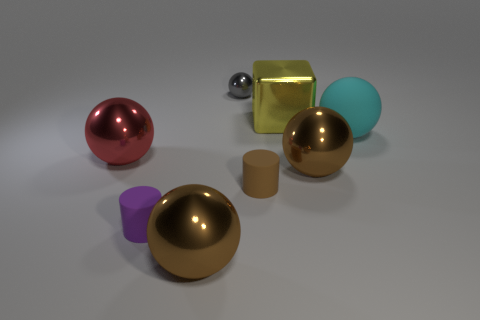Subtract all gray metal balls. How many balls are left? 4 Subtract all gray cylinders. How many brown spheres are left? 2 Subtract 2 spheres. How many spheres are left? 3 Subtract all red balls. How many balls are left? 4 Add 1 large shiny cubes. How many objects exist? 9 Subtract all cylinders. How many objects are left? 6 Subtract all gray spheres. Subtract all purple blocks. How many spheres are left? 4 Add 4 rubber objects. How many rubber objects are left? 7 Add 4 gray metallic things. How many gray metallic things exist? 5 Subtract 2 brown balls. How many objects are left? 6 